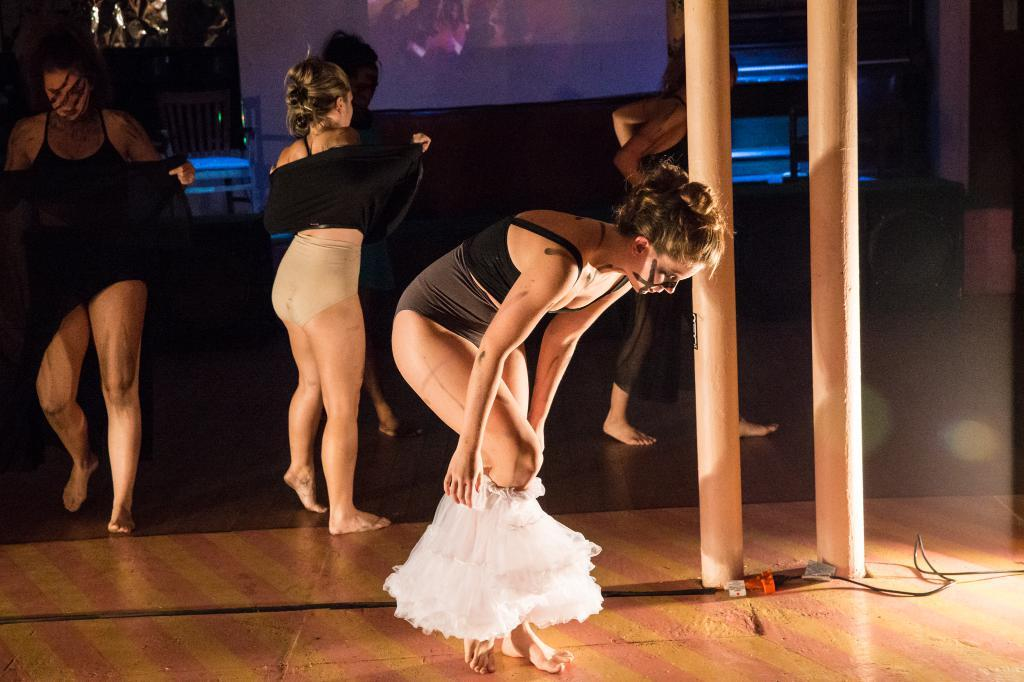What can be seen in the image? There are women standing in the image. Where are the women standing? The women are standing on the floor. What is visible in the background of the image? There is a display screen and a chair in the background of the image. What type of instrument is the father playing in the image? There is no father or instrument present in the image. 